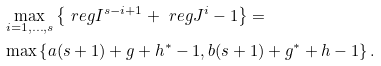<formula> <loc_0><loc_0><loc_500><loc_500>& \max _ { i = 1 , \dots , s } \left \{ \ r e g I ^ { s - i + 1 } + \ r e g J ^ { i } - 1 \right \} = \\ & \max \left \{ a ( s + 1 ) + g + h ^ { * } - 1 , b ( s + 1 ) + g ^ { * } + h - 1 \right \} .</formula> 